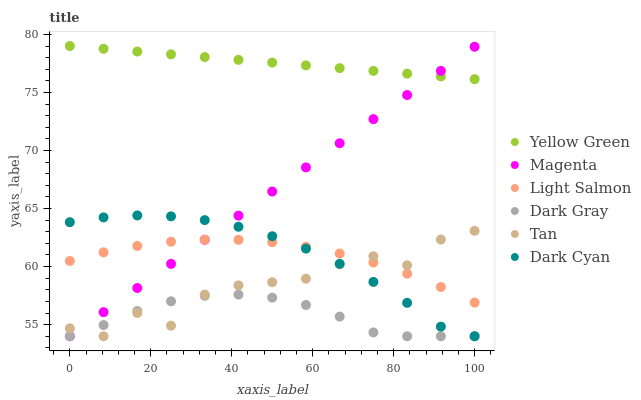Does Dark Gray have the minimum area under the curve?
Answer yes or no. Yes. Does Yellow Green have the maximum area under the curve?
Answer yes or no. Yes. Does Yellow Green have the minimum area under the curve?
Answer yes or no. No. Does Dark Gray have the maximum area under the curve?
Answer yes or no. No. Is Magenta the smoothest?
Answer yes or no. Yes. Is Tan the roughest?
Answer yes or no. Yes. Is Yellow Green the smoothest?
Answer yes or no. No. Is Yellow Green the roughest?
Answer yes or no. No. Does Dark Gray have the lowest value?
Answer yes or no. Yes. Does Yellow Green have the lowest value?
Answer yes or no. No. Does Yellow Green have the highest value?
Answer yes or no. Yes. Does Dark Gray have the highest value?
Answer yes or no. No. Is Dark Gray less than Light Salmon?
Answer yes or no. Yes. Is Yellow Green greater than Tan?
Answer yes or no. Yes. Does Dark Cyan intersect Light Salmon?
Answer yes or no. Yes. Is Dark Cyan less than Light Salmon?
Answer yes or no. No. Is Dark Cyan greater than Light Salmon?
Answer yes or no. No. Does Dark Gray intersect Light Salmon?
Answer yes or no. No. 